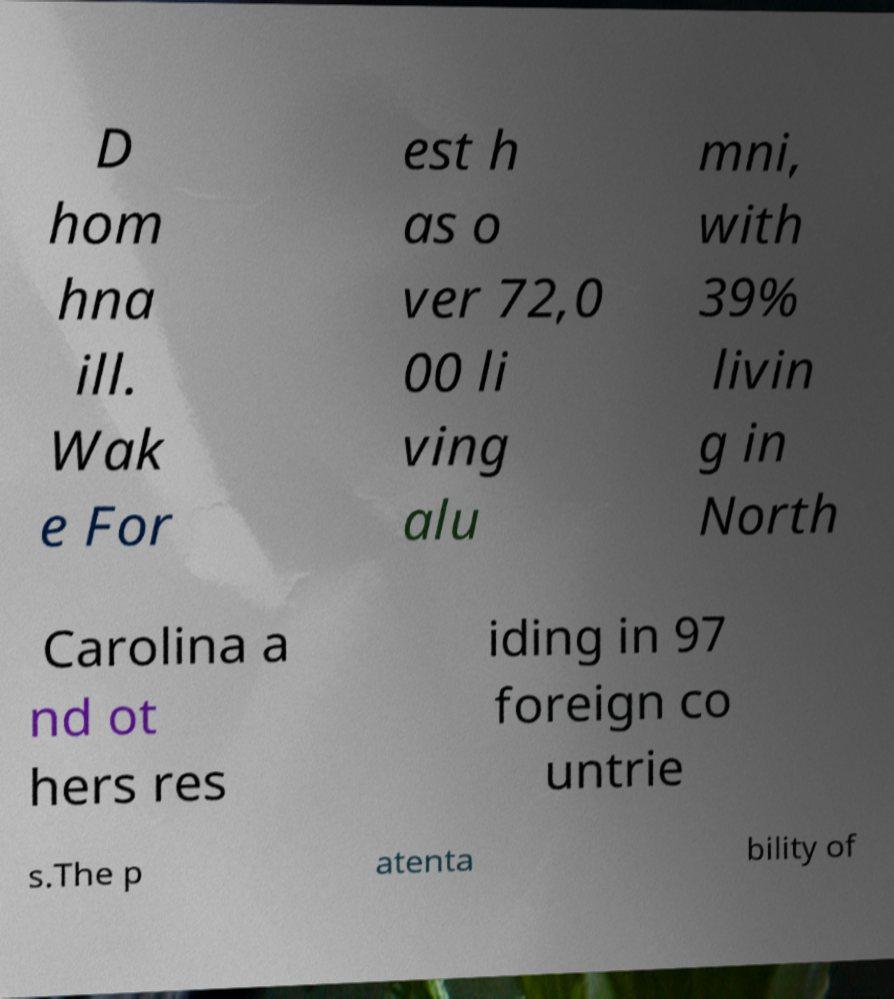For documentation purposes, I need the text within this image transcribed. Could you provide that? D hom hna ill. Wak e For est h as o ver 72,0 00 li ving alu mni, with 39% livin g in North Carolina a nd ot hers res iding in 97 foreign co untrie s.The p atenta bility of 